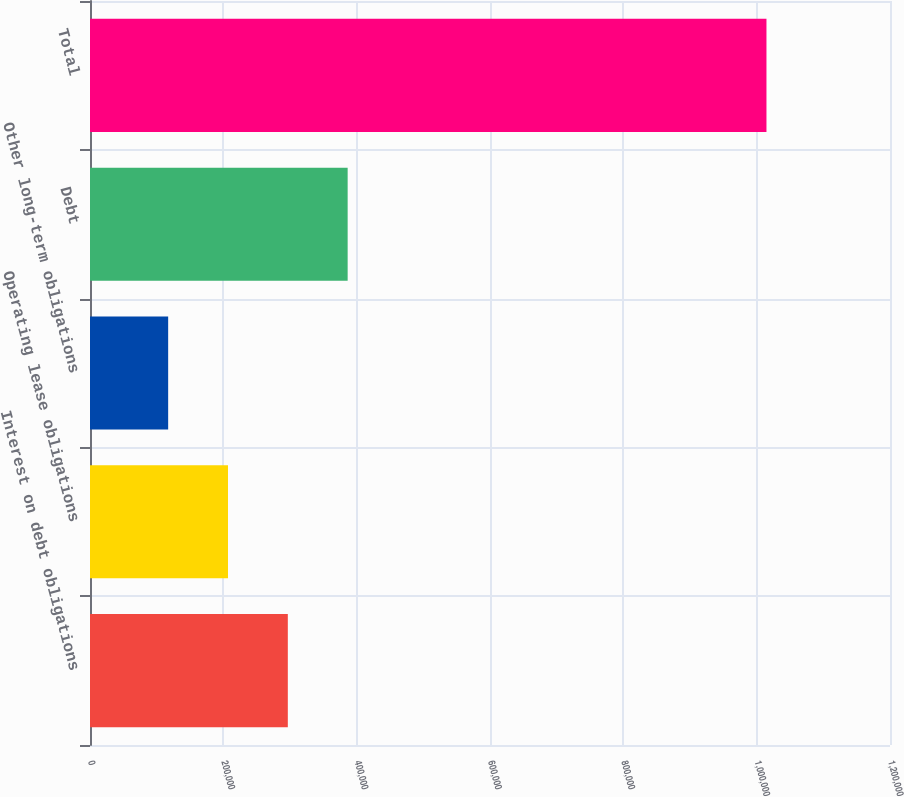Convert chart to OTSL. <chart><loc_0><loc_0><loc_500><loc_500><bar_chart><fcel>Interest on debt obligations<fcel>Operating lease obligations<fcel>Other long-term obligations<fcel>Debt<fcel>Total<nl><fcel>296736<fcel>206991<fcel>117246<fcel>386481<fcel>1.0147e+06<nl></chart> 